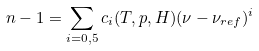<formula> <loc_0><loc_0><loc_500><loc_500>n - 1 = \sum _ { i = 0 , 5 } c _ { i } ( T , p , H ) ( \nu - \nu _ { r e f } ) ^ { i }</formula> 